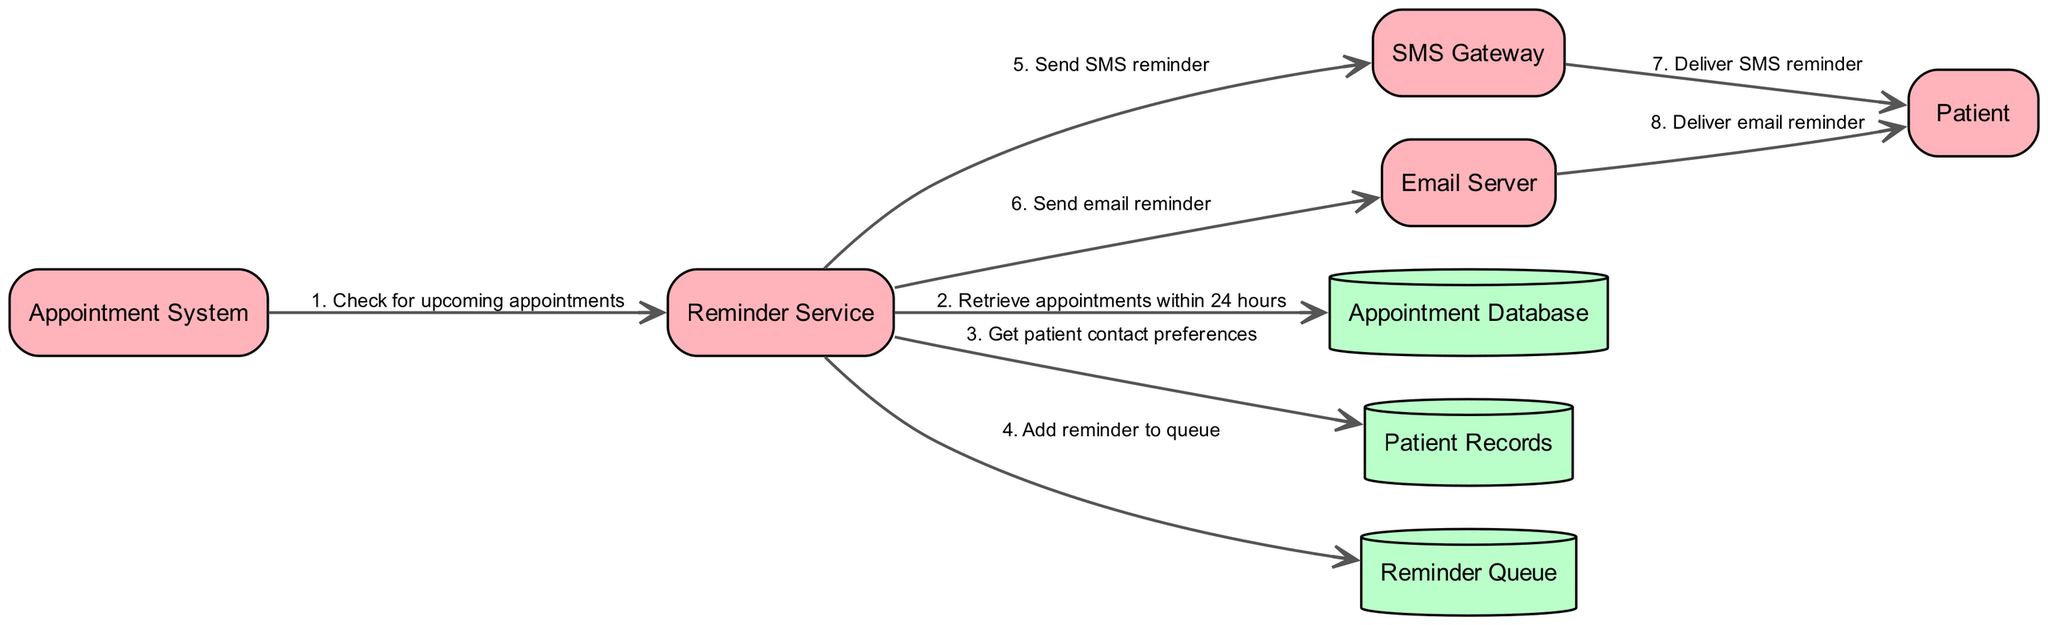What are the actors in the diagram? The actors in the diagram are listed at the top and consist of "Patient", "Appointment System", "Reminder Service", "SMS Gateway", and "Email Server".
Answer: Patient, Appointment System, Reminder Service, SMS Gateway, Email Server How many objects are shown in the diagram? The diagram includes three object nodes which are "Appointment Database", "Patient Records", and "Reminder Queue".
Answer: 3 What is the first message sent in the sequence? The first message sent in the sequence is from "Appointment System" to "Reminder Service" with the text "Check for upcoming appointments".
Answer: Check for upcoming appointments Which service is responsible for sending reminders? The "Reminder Service" is responsible for sending both SMS and email reminders as shown in the connections to the "SMS Gateway" and "Email Server".
Answer: Reminder Service What preference does the Reminder Service retrieve? The "Reminder Service" retrieves "patient contact preferences" from "Patient Records" to determine how to send reminders.
Answer: Patient contact preferences Which actor delivers the SMS reminder? The "SMS Gateway" delivers the SMS reminder to the "Patient" actor in the sequence diagram.
Answer: SMS Gateway How many messages are sent from the Reminder Service? The "Reminder Service" sends three messages: one to add a reminder to the queue, one to the SMS Gateway, and one to the Email Server.
Answer: 3 What is the last action taken in the sequence? The last action in the sequence is the "Email Server" delivering the email reminder to the "Patient".
Answer: Deliver email reminder 